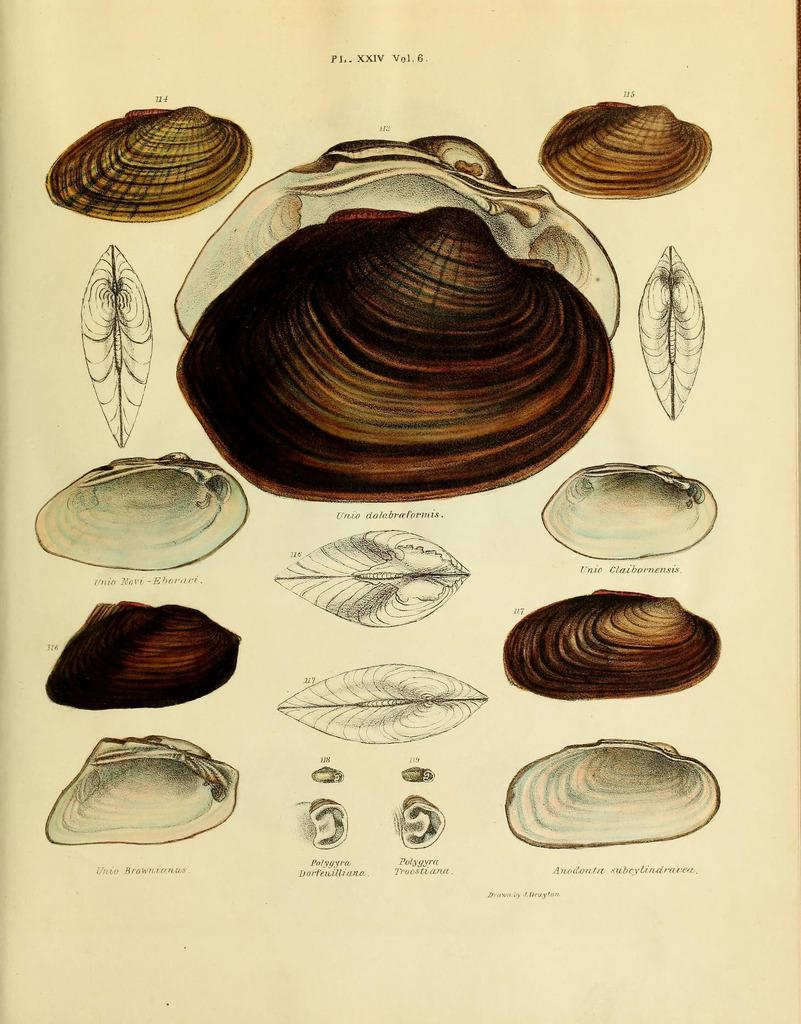What is the main subject of the image? The main subject of the image is a paper. What is depicted on the paper? The paper contains images of shells. What type of cover is protecting the queen in the image? There is no queen or cover present in the image; it only features a paper with images of shells. 